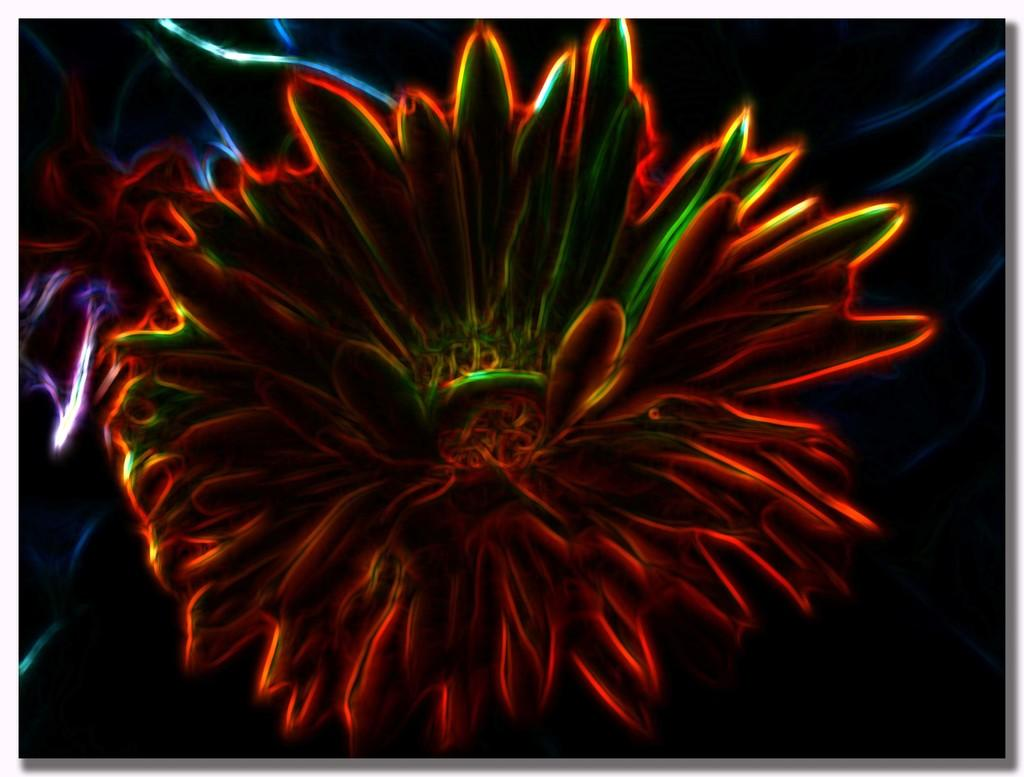What can be observed about the image's appearance? The image is edited. What type of plant is present in the image? There is a flower in the image. What type of treatment is being administered to the flower in the image? There is no indication in the image that the flower is receiving any treatment. How is the flower being distributed in the image? The image does not show the flower being distributed; it is simply present in the image. 